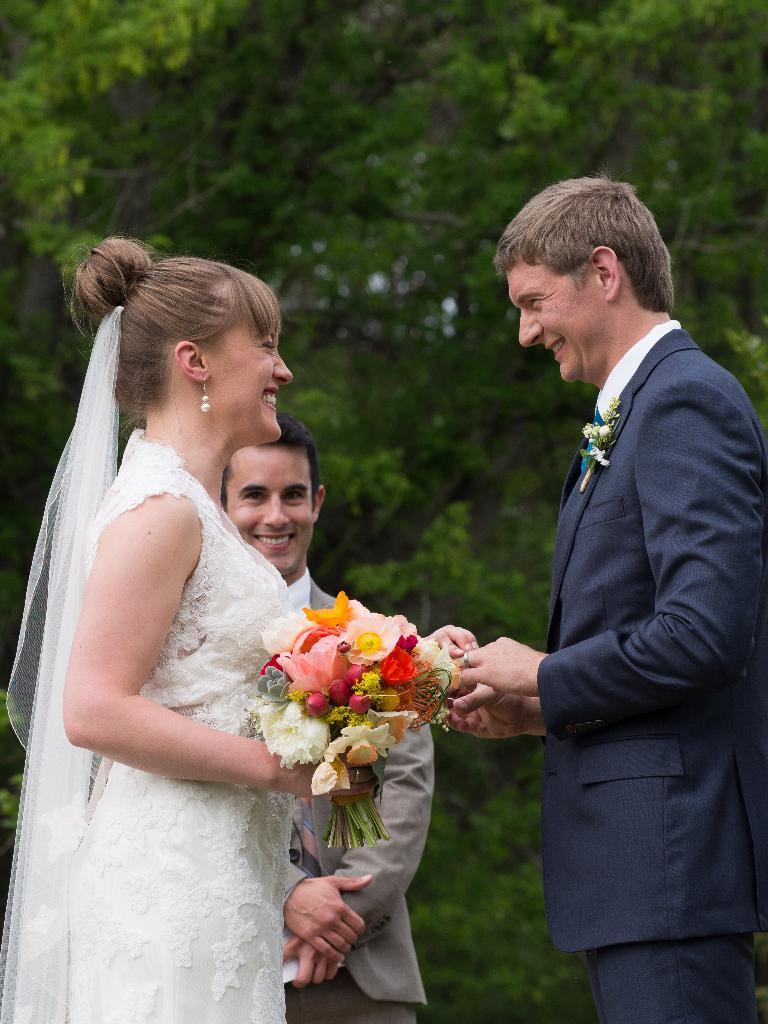How many people are present in the image? There are two people, a man and a woman, present in the image. What is the woman wearing that covers her head? The woman is wearing a veil. What is the woman holding in the image? The woman is holding a bouquet. Can you describe the background of the image? There is a person and trees in the background of the image. What type of music can be heard playing in the background of the image? There is no music present in the image, as it is a still photograph. Can you see a snail crawling on the woman's veil in the image? There is no snail visible on the woman's veil in the image. 